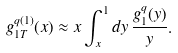<formula> <loc_0><loc_0><loc_500><loc_500>g _ { 1 T } ^ { q ( 1 ) } ( x ) \approx x \int _ { x } ^ { 1 } d y \, \frac { g _ { 1 } ^ { q } ( y ) } { y } .</formula> 